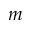<formula> <loc_0><loc_0><loc_500><loc_500>m</formula> 